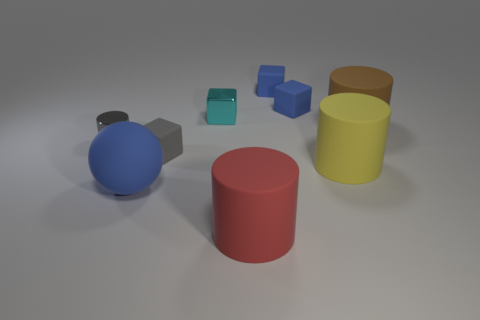What is the shape of the metallic object that is right of the large object that is left of the cyan metal thing?
Provide a succinct answer. Cube. Are there more large red rubber things that are in front of the small cyan metal cube than big cyan rubber cubes?
Offer a terse response. Yes. Is the shape of the metal thing that is to the right of the gray matte thing the same as  the gray matte object?
Ensure brevity in your answer.  Yes. Is there a purple object that has the same shape as the red matte object?
Offer a very short reply. No. What number of things are small shiny objects on the left side of the blue sphere or tiny blue things?
Your answer should be very brief. 3. Is the number of tiny brown things greater than the number of small blocks?
Your response must be concise. No. Is there a cyan shiny object that has the same size as the red object?
Make the answer very short. No. What number of things are gray rubber objects that are in front of the gray cylinder or rubber blocks that are to the right of the gray rubber cube?
Offer a terse response. 3. What color is the large matte object behind the tiny gray thing that is in front of the gray metallic cylinder?
Your answer should be very brief. Brown. What is the color of the small object that is the same material as the tiny cylinder?
Offer a very short reply. Cyan. 